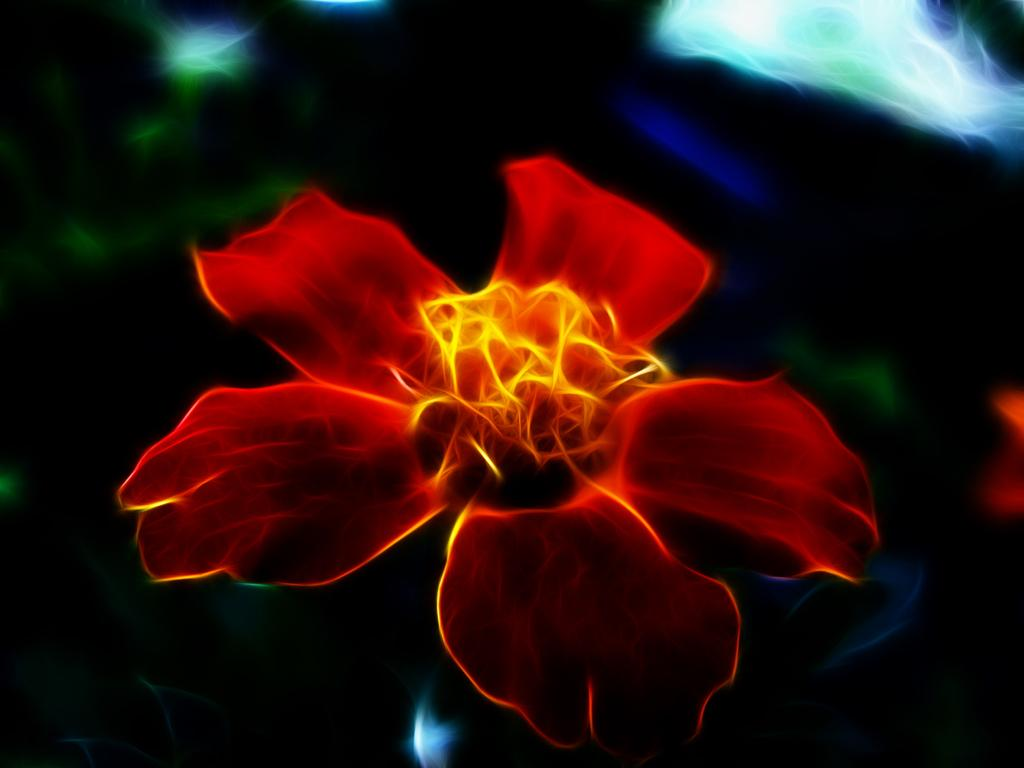What type of picture is present in the image? The image contains an animated picture. Can you describe the subject of the animated picture? The animated picture is of a flower. How many babies are crawling in the field in the image? There are no babies or fields present in the image; it contains an animated picture of a flower. 